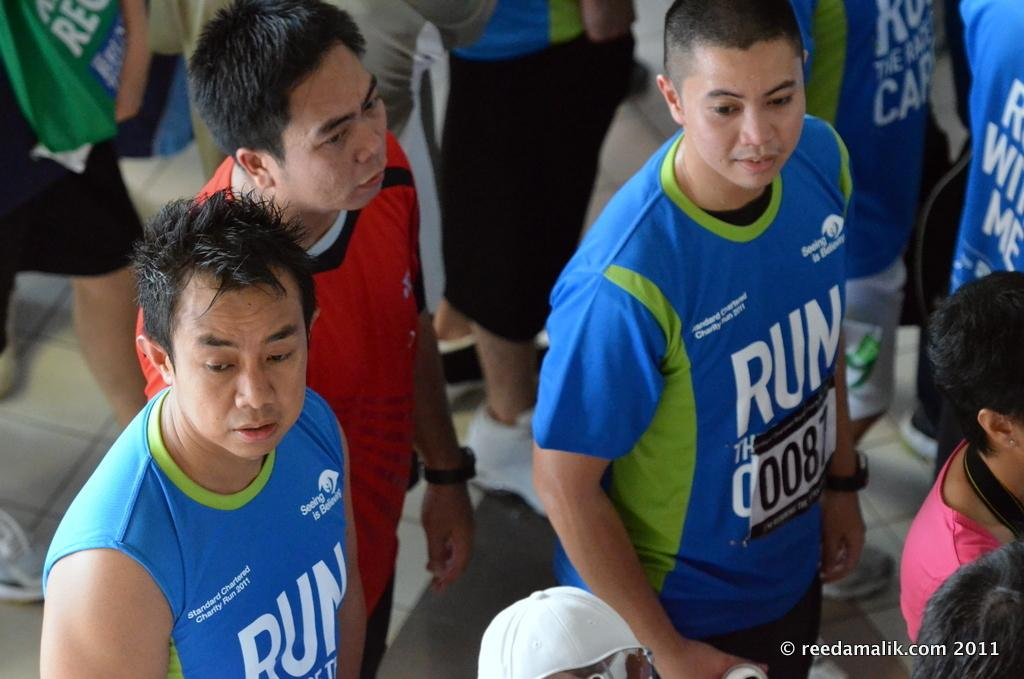What can be seen in the image? There is a group of people in the image. What are the people wearing? The people are wearing uniform t-shirts. What is written on the t-shirts? The t-shirts have uniform text. Is there any text in the image besides the text on the t-shirts? Yes, there is text in the bottom right corner of the image. How many elbows can be seen in the image? There is no specific mention of elbows in the provided facts, so it is impossible to determine the number of elbows visible in the image. 